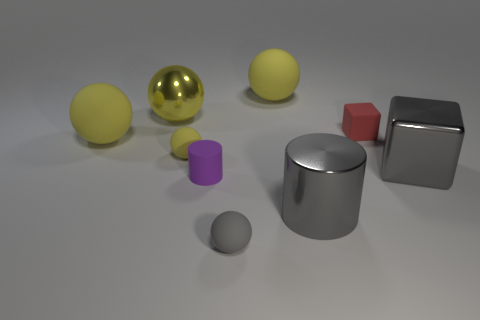Are the big ball that is to the right of the tiny cylinder and the tiny red block made of the same material?
Ensure brevity in your answer.  Yes. How many things are either big gray rubber cylinders or large gray metal things that are in front of the purple object?
Your answer should be compact. 1. What number of things are left of the small ball behind the rubber ball that is in front of the large gray cube?
Offer a terse response. 2. There is a gray metallic object behind the large cylinder; is its shape the same as the tiny gray rubber object?
Give a very brief answer. No. There is a tiny rubber sphere in front of the small purple matte cylinder; is there a small thing right of it?
Offer a very short reply. Yes. What number of gray metallic cylinders are there?
Your answer should be very brief. 1. There is a sphere that is both right of the tiny matte cylinder and behind the red thing; what is its color?
Provide a short and direct response. Yellow. The yellow shiny thing that is the same shape as the tiny gray rubber object is what size?
Your response must be concise. Large. How many cylinders are the same size as the red rubber thing?
Your answer should be very brief. 1. What is the material of the tiny cylinder?
Offer a terse response. Rubber. 